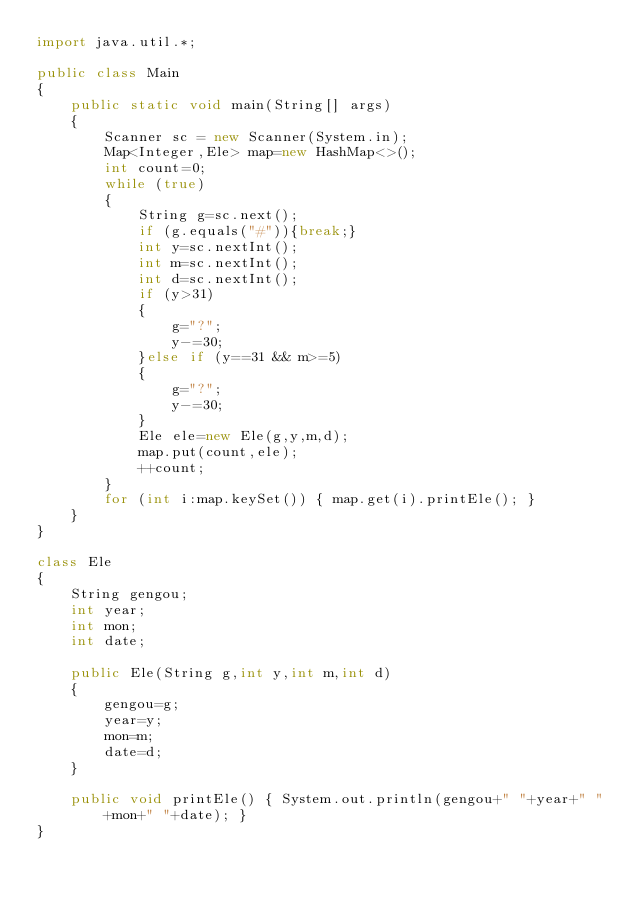<code> <loc_0><loc_0><loc_500><loc_500><_Java_>import java.util.*;

public class Main
{
    public static void main(String[] args)
    {
        Scanner sc = new Scanner(System.in);
        Map<Integer,Ele> map=new HashMap<>();
        int count=0;
        while (true)
        {
            String g=sc.next();
            if (g.equals("#")){break;}
            int y=sc.nextInt();
            int m=sc.nextInt();
            int d=sc.nextInt();
            if (y>31)
            {
                g="?";
                y-=30;
            }else if (y==31 && m>=5)
            {
                g="?";
                y-=30;
            }
            Ele ele=new Ele(g,y,m,d);
            map.put(count,ele);
            ++count;
        }
        for (int i:map.keySet()) { map.get(i).printEle(); }
    }
}

class Ele
{
    String gengou;
    int year;
    int mon;
    int date;

    public Ele(String g,int y,int m,int d)
    {
        gengou=g;
        year=y;
        mon=m;
        date=d;
    }

    public void printEle() { System.out.println(gengou+" "+year+" "+mon+" "+date); }
}
</code> 